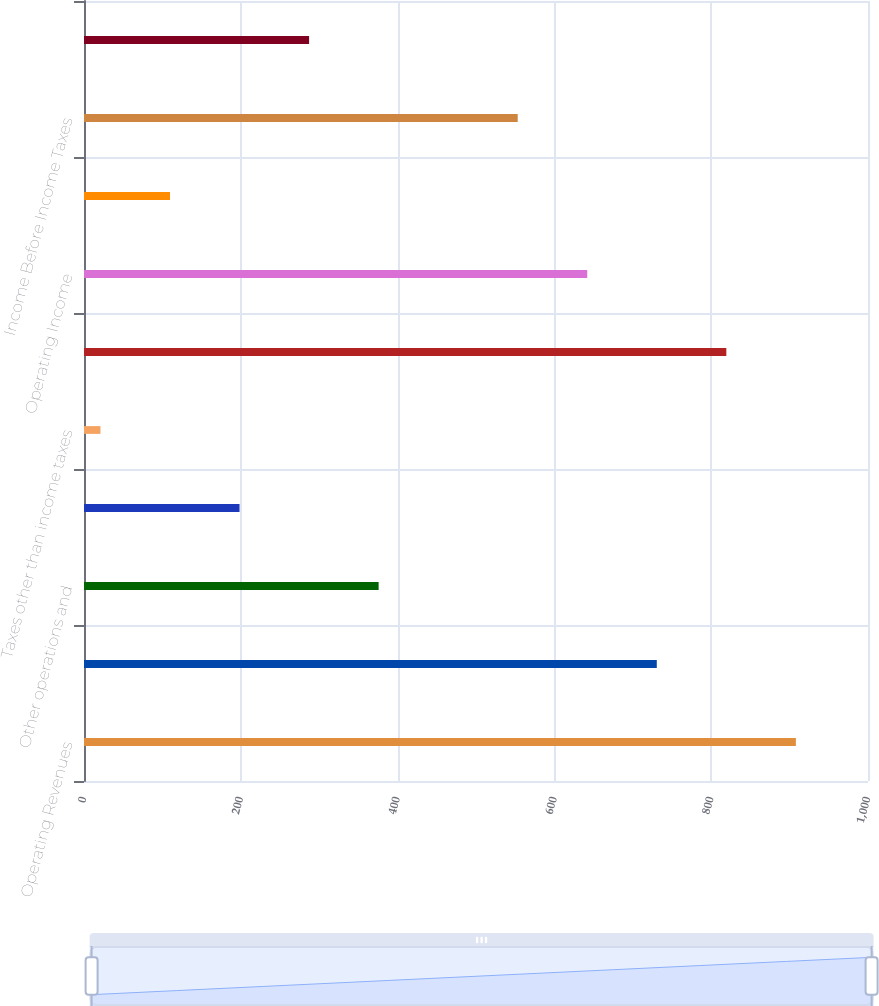Convert chart. <chart><loc_0><loc_0><loc_500><loc_500><bar_chart><fcel>Operating Revenues<fcel>Fuel<fcel>Other operations and<fcel>Depreciation and amortization<fcel>Taxes other than income taxes<fcel>Total operating expenses<fcel>Operating Income<fcel>Interest Charges<fcel>Income Before Income Taxes<fcel>Income Taxes<nl><fcel>908<fcel>730.6<fcel>375.8<fcel>198.4<fcel>21<fcel>819.3<fcel>641.9<fcel>109.7<fcel>553.2<fcel>287.1<nl></chart> 